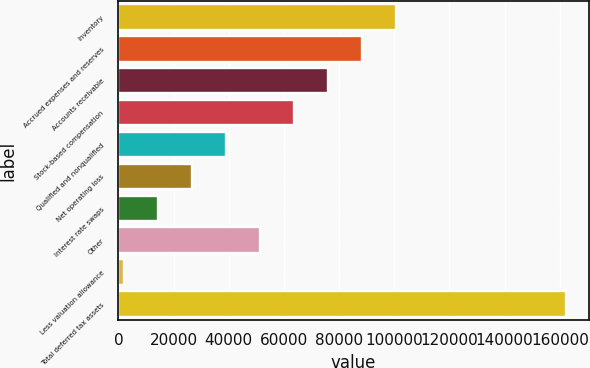Convert chart. <chart><loc_0><loc_0><loc_500><loc_500><bar_chart><fcel>Inventory<fcel>Accrued expenses and reserves<fcel>Accounts receivable<fcel>Stock-based compensation<fcel>Qualified and nonqualified<fcel>Net operating loss<fcel>Interest rate swaps<fcel>Other<fcel>Less valuation allowance<fcel>Total deferred tax assets<nl><fcel>100673<fcel>88328.1<fcel>75982.8<fcel>63637.5<fcel>38946.9<fcel>26601.6<fcel>14256.3<fcel>51292.2<fcel>1911<fcel>162400<nl></chart> 